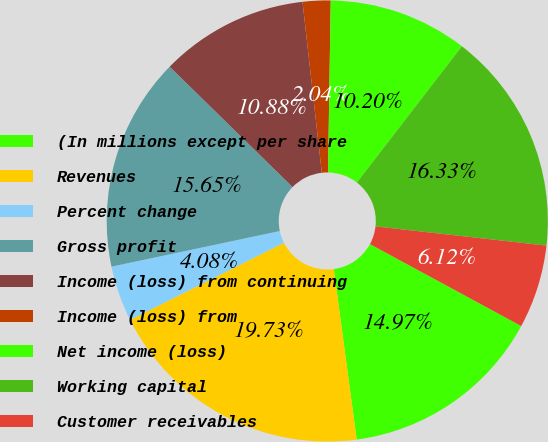Convert chart. <chart><loc_0><loc_0><loc_500><loc_500><pie_chart><fcel>(In millions except per share<fcel>Revenues<fcel>Percent change<fcel>Gross profit<fcel>Income (loss) from continuing<fcel>Income (loss) from<fcel>Net income (loss)<fcel>Working capital<fcel>Customer receivables<nl><fcel>14.97%<fcel>19.73%<fcel>4.08%<fcel>15.65%<fcel>10.88%<fcel>2.04%<fcel>10.2%<fcel>16.33%<fcel>6.12%<nl></chart> 